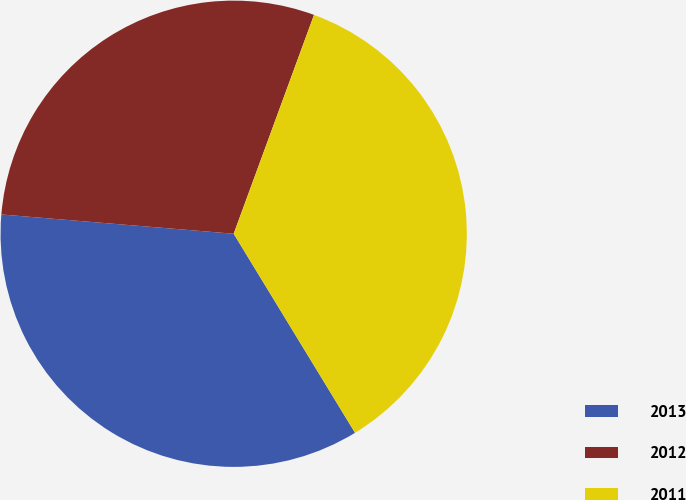Convert chart to OTSL. <chart><loc_0><loc_0><loc_500><loc_500><pie_chart><fcel>2013<fcel>2012<fcel>2011<nl><fcel>35.03%<fcel>29.28%<fcel>35.69%<nl></chart> 